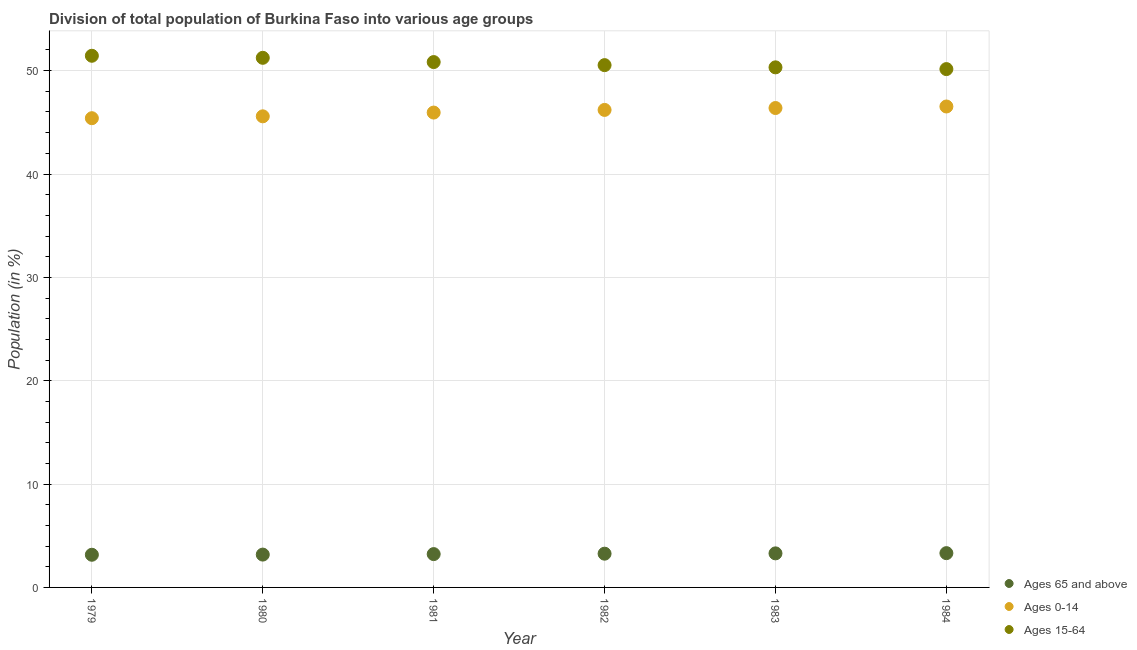How many different coloured dotlines are there?
Offer a very short reply. 3. What is the percentage of population within the age-group of 65 and above in 1981?
Provide a succinct answer. 3.22. Across all years, what is the maximum percentage of population within the age-group 15-64?
Your answer should be very brief. 51.44. Across all years, what is the minimum percentage of population within the age-group 15-64?
Make the answer very short. 50.15. In which year was the percentage of population within the age-group 0-14 maximum?
Your answer should be compact. 1984. In which year was the percentage of population within the age-group of 65 and above minimum?
Make the answer very short. 1979. What is the total percentage of population within the age-group of 65 and above in the graph?
Give a very brief answer. 19.44. What is the difference between the percentage of population within the age-group 15-64 in 1980 and that in 1983?
Offer a terse response. 0.92. What is the difference between the percentage of population within the age-group of 65 and above in 1982 and the percentage of population within the age-group 15-64 in 1981?
Offer a very short reply. -47.57. What is the average percentage of population within the age-group 0-14 per year?
Make the answer very short. 46.01. In the year 1984, what is the difference between the percentage of population within the age-group of 65 and above and percentage of population within the age-group 15-64?
Offer a very short reply. -46.83. What is the ratio of the percentage of population within the age-group 15-64 in 1979 to that in 1983?
Your answer should be compact. 1.02. What is the difference between the highest and the second highest percentage of population within the age-group of 65 and above?
Keep it short and to the point. 0.02. What is the difference between the highest and the lowest percentage of population within the age-group 0-14?
Your response must be concise. 1.13. Is the sum of the percentage of population within the age-group of 65 and above in 1982 and 1983 greater than the maximum percentage of population within the age-group 15-64 across all years?
Make the answer very short. No. Is it the case that in every year, the sum of the percentage of population within the age-group of 65 and above and percentage of population within the age-group 0-14 is greater than the percentage of population within the age-group 15-64?
Provide a short and direct response. No. Does the percentage of population within the age-group 0-14 monotonically increase over the years?
Provide a short and direct response. Yes. Is the percentage of population within the age-group 15-64 strictly greater than the percentage of population within the age-group 0-14 over the years?
Keep it short and to the point. Yes. How many dotlines are there?
Offer a very short reply. 3. Are the values on the major ticks of Y-axis written in scientific E-notation?
Offer a very short reply. No. Does the graph contain any zero values?
Your response must be concise. No. How many legend labels are there?
Make the answer very short. 3. How are the legend labels stacked?
Provide a short and direct response. Vertical. What is the title of the graph?
Offer a very short reply. Division of total population of Burkina Faso into various age groups
. Does "Social Protection" appear as one of the legend labels in the graph?
Your answer should be compact. No. What is the label or title of the X-axis?
Your answer should be very brief. Year. What is the label or title of the Y-axis?
Provide a short and direct response. Population (in %). What is the Population (in %) in Ages 65 and above in 1979?
Your answer should be compact. 3.16. What is the Population (in %) of Ages 0-14 in 1979?
Make the answer very short. 45.4. What is the Population (in %) in Ages 15-64 in 1979?
Ensure brevity in your answer.  51.44. What is the Population (in %) of Ages 65 and above in 1980?
Offer a terse response. 3.18. What is the Population (in %) in Ages 0-14 in 1980?
Offer a terse response. 45.58. What is the Population (in %) of Ages 15-64 in 1980?
Your answer should be very brief. 51.24. What is the Population (in %) of Ages 65 and above in 1981?
Ensure brevity in your answer.  3.22. What is the Population (in %) in Ages 0-14 in 1981?
Your response must be concise. 45.94. What is the Population (in %) in Ages 15-64 in 1981?
Your answer should be very brief. 50.83. What is the Population (in %) in Ages 65 and above in 1982?
Make the answer very short. 3.26. What is the Population (in %) of Ages 0-14 in 1982?
Ensure brevity in your answer.  46.2. What is the Population (in %) in Ages 15-64 in 1982?
Provide a succinct answer. 50.53. What is the Population (in %) in Ages 65 and above in 1983?
Keep it short and to the point. 3.3. What is the Population (in %) in Ages 0-14 in 1983?
Make the answer very short. 46.38. What is the Population (in %) in Ages 15-64 in 1983?
Keep it short and to the point. 50.32. What is the Population (in %) of Ages 65 and above in 1984?
Make the answer very short. 3.32. What is the Population (in %) of Ages 0-14 in 1984?
Your answer should be very brief. 46.53. What is the Population (in %) in Ages 15-64 in 1984?
Make the answer very short. 50.15. Across all years, what is the maximum Population (in %) of Ages 65 and above?
Keep it short and to the point. 3.32. Across all years, what is the maximum Population (in %) in Ages 0-14?
Your response must be concise. 46.53. Across all years, what is the maximum Population (in %) in Ages 15-64?
Keep it short and to the point. 51.44. Across all years, what is the minimum Population (in %) of Ages 65 and above?
Your answer should be compact. 3.16. Across all years, what is the minimum Population (in %) in Ages 0-14?
Your response must be concise. 45.4. Across all years, what is the minimum Population (in %) in Ages 15-64?
Your answer should be very brief. 50.15. What is the total Population (in %) in Ages 65 and above in the graph?
Offer a very short reply. 19.44. What is the total Population (in %) of Ages 0-14 in the graph?
Your response must be concise. 276.04. What is the total Population (in %) in Ages 15-64 in the graph?
Your response must be concise. 304.52. What is the difference between the Population (in %) of Ages 65 and above in 1979 and that in 1980?
Give a very brief answer. -0.02. What is the difference between the Population (in %) of Ages 0-14 in 1979 and that in 1980?
Your response must be concise. -0.18. What is the difference between the Population (in %) in Ages 15-64 in 1979 and that in 1980?
Your response must be concise. 0.2. What is the difference between the Population (in %) in Ages 65 and above in 1979 and that in 1981?
Ensure brevity in your answer.  -0.06. What is the difference between the Population (in %) in Ages 0-14 in 1979 and that in 1981?
Provide a succinct answer. -0.55. What is the difference between the Population (in %) in Ages 15-64 in 1979 and that in 1981?
Your answer should be compact. 0.61. What is the difference between the Population (in %) of Ages 65 and above in 1979 and that in 1982?
Ensure brevity in your answer.  -0.1. What is the difference between the Population (in %) of Ages 0-14 in 1979 and that in 1982?
Offer a terse response. -0.8. What is the difference between the Population (in %) of Ages 15-64 in 1979 and that in 1982?
Provide a short and direct response. 0.91. What is the difference between the Population (in %) of Ages 65 and above in 1979 and that in 1983?
Provide a short and direct response. -0.13. What is the difference between the Population (in %) in Ages 0-14 in 1979 and that in 1983?
Offer a very short reply. -0.99. What is the difference between the Population (in %) of Ages 15-64 in 1979 and that in 1983?
Provide a succinct answer. 1.12. What is the difference between the Population (in %) of Ages 65 and above in 1979 and that in 1984?
Give a very brief answer. -0.16. What is the difference between the Population (in %) in Ages 0-14 in 1979 and that in 1984?
Offer a terse response. -1.13. What is the difference between the Population (in %) in Ages 15-64 in 1979 and that in 1984?
Provide a succinct answer. 1.29. What is the difference between the Population (in %) in Ages 65 and above in 1980 and that in 1981?
Your answer should be compact. -0.05. What is the difference between the Population (in %) in Ages 0-14 in 1980 and that in 1981?
Keep it short and to the point. -0.36. What is the difference between the Population (in %) in Ages 15-64 in 1980 and that in 1981?
Your answer should be compact. 0.41. What is the difference between the Population (in %) in Ages 65 and above in 1980 and that in 1982?
Make the answer very short. -0.09. What is the difference between the Population (in %) of Ages 0-14 in 1980 and that in 1982?
Give a very brief answer. -0.62. What is the difference between the Population (in %) in Ages 15-64 in 1980 and that in 1982?
Provide a succinct answer. 0.71. What is the difference between the Population (in %) in Ages 65 and above in 1980 and that in 1983?
Your response must be concise. -0.12. What is the difference between the Population (in %) in Ages 0-14 in 1980 and that in 1983?
Make the answer very short. -0.8. What is the difference between the Population (in %) in Ages 15-64 in 1980 and that in 1983?
Offer a terse response. 0.92. What is the difference between the Population (in %) of Ages 65 and above in 1980 and that in 1984?
Provide a short and direct response. -0.14. What is the difference between the Population (in %) of Ages 0-14 in 1980 and that in 1984?
Your response must be concise. -0.95. What is the difference between the Population (in %) of Ages 15-64 in 1980 and that in 1984?
Offer a very short reply. 1.09. What is the difference between the Population (in %) in Ages 65 and above in 1981 and that in 1982?
Keep it short and to the point. -0.04. What is the difference between the Population (in %) in Ages 0-14 in 1981 and that in 1982?
Provide a succinct answer. -0.26. What is the difference between the Population (in %) of Ages 15-64 in 1981 and that in 1982?
Offer a terse response. 0.3. What is the difference between the Population (in %) of Ages 65 and above in 1981 and that in 1983?
Your response must be concise. -0.07. What is the difference between the Population (in %) of Ages 0-14 in 1981 and that in 1983?
Offer a terse response. -0.44. What is the difference between the Population (in %) of Ages 15-64 in 1981 and that in 1983?
Make the answer very short. 0.51. What is the difference between the Population (in %) in Ages 65 and above in 1981 and that in 1984?
Keep it short and to the point. -0.09. What is the difference between the Population (in %) in Ages 0-14 in 1981 and that in 1984?
Your response must be concise. -0.59. What is the difference between the Population (in %) in Ages 15-64 in 1981 and that in 1984?
Ensure brevity in your answer.  0.68. What is the difference between the Population (in %) of Ages 65 and above in 1982 and that in 1983?
Your response must be concise. -0.03. What is the difference between the Population (in %) in Ages 0-14 in 1982 and that in 1983?
Your response must be concise. -0.18. What is the difference between the Population (in %) of Ages 15-64 in 1982 and that in 1983?
Your answer should be very brief. 0.21. What is the difference between the Population (in %) of Ages 65 and above in 1982 and that in 1984?
Make the answer very short. -0.05. What is the difference between the Population (in %) in Ages 0-14 in 1982 and that in 1984?
Offer a terse response. -0.33. What is the difference between the Population (in %) in Ages 15-64 in 1982 and that in 1984?
Provide a short and direct response. 0.38. What is the difference between the Population (in %) of Ages 65 and above in 1983 and that in 1984?
Your answer should be compact. -0.02. What is the difference between the Population (in %) of Ages 0-14 in 1983 and that in 1984?
Your answer should be compact. -0.15. What is the difference between the Population (in %) in Ages 15-64 in 1983 and that in 1984?
Offer a very short reply. 0.17. What is the difference between the Population (in %) of Ages 65 and above in 1979 and the Population (in %) of Ages 0-14 in 1980?
Your answer should be very brief. -42.42. What is the difference between the Population (in %) in Ages 65 and above in 1979 and the Population (in %) in Ages 15-64 in 1980?
Ensure brevity in your answer.  -48.08. What is the difference between the Population (in %) in Ages 0-14 in 1979 and the Population (in %) in Ages 15-64 in 1980?
Offer a terse response. -5.84. What is the difference between the Population (in %) in Ages 65 and above in 1979 and the Population (in %) in Ages 0-14 in 1981?
Your answer should be very brief. -42.78. What is the difference between the Population (in %) of Ages 65 and above in 1979 and the Population (in %) of Ages 15-64 in 1981?
Give a very brief answer. -47.67. What is the difference between the Population (in %) of Ages 0-14 in 1979 and the Population (in %) of Ages 15-64 in 1981?
Your response must be concise. -5.43. What is the difference between the Population (in %) in Ages 65 and above in 1979 and the Population (in %) in Ages 0-14 in 1982?
Provide a succinct answer. -43.04. What is the difference between the Population (in %) in Ages 65 and above in 1979 and the Population (in %) in Ages 15-64 in 1982?
Make the answer very short. -47.37. What is the difference between the Population (in %) in Ages 0-14 in 1979 and the Population (in %) in Ages 15-64 in 1982?
Your answer should be compact. -5.13. What is the difference between the Population (in %) in Ages 65 and above in 1979 and the Population (in %) in Ages 0-14 in 1983?
Give a very brief answer. -43.22. What is the difference between the Population (in %) in Ages 65 and above in 1979 and the Population (in %) in Ages 15-64 in 1983?
Keep it short and to the point. -47.16. What is the difference between the Population (in %) in Ages 0-14 in 1979 and the Population (in %) in Ages 15-64 in 1983?
Your answer should be very brief. -4.92. What is the difference between the Population (in %) of Ages 65 and above in 1979 and the Population (in %) of Ages 0-14 in 1984?
Make the answer very short. -43.37. What is the difference between the Population (in %) of Ages 65 and above in 1979 and the Population (in %) of Ages 15-64 in 1984?
Make the answer very short. -46.99. What is the difference between the Population (in %) in Ages 0-14 in 1979 and the Population (in %) in Ages 15-64 in 1984?
Offer a very short reply. -4.75. What is the difference between the Population (in %) of Ages 65 and above in 1980 and the Population (in %) of Ages 0-14 in 1981?
Your answer should be compact. -42.77. What is the difference between the Population (in %) in Ages 65 and above in 1980 and the Population (in %) in Ages 15-64 in 1981?
Make the answer very short. -47.65. What is the difference between the Population (in %) in Ages 0-14 in 1980 and the Population (in %) in Ages 15-64 in 1981?
Your answer should be very brief. -5.25. What is the difference between the Population (in %) of Ages 65 and above in 1980 and the Population (in %) of Ages 0-14 in 1982?
Keep it short and to the point. -43.02. What is the difference between the Population (in %) in Ages 65 and above in 1980 and the Population (in %) in Ages 15-64 in 1982?
Ensure brevity in your answer.  -47.36. What is the difference between the Population (in %) of Ages 0-14 in 1980 and the Population (in %) of Ages 15-64 in 1982?
Offer a very short reply. -4.95. What is the difference between the Population (in %) in Ages 65 and above in 1980 and the Population (in %) in Ages 0-14 in 1983?
Your answer should be compact. -43.21. What is the difference between the Population (in %) in Ages 65 and above in 1980 and the Population (in %) in Ages 15-64 in 1983?
Keep it short and to the point. -47.14. What is the difference between the Population (in %) in Ages 0-14 in 1980 and the Population (in %) in Ages 15-64 in 1983?
Give a very brief answer. -4.74. What is the difference between the Population (in %) in Ages 65 and above in 1980 and the Population (in %) in Ages 0-14 in 1984?
Ensure brevity in your answer.  -43.36. What is the difference between the Population (in %) in Ages 65 and above in 1980 and the Population (in %) in Ages 15-64 in 1984?
Offer a very short reply. -46.97. What is the difference between the Population (in %) in Ages 0-14 in 1980 and the Population (in %) in Ages 15-64 in 1984?
Your answer should be compact. -4.57. What is the difference between the Population (in %) of Ages 65 and above in 1981 and the Population (in %) of Ages 0-14 in 1982?
Provide a short and direct response. -42.98. What is the difference between the Population (in %) of Ages 65 and above in 1981 and the Population (in %) of Ages 15-64 in 1982?
Your answer should be compact. -47.31. What is the difference between the Population (in %) in Ages 0-14 in 1981 and the Population (in %) in Ages 15-64 in 1982?
Your answer should be very brief. -4.59. What is the difference between the Population (in %) in Ages 65 and above in 1981 and the Population (in %) in Ages 0-14 in 1983?
Offer a terse response. -43.16. What is the difference between the Population (in %) of Ages 65 and above in 1981 and the Population (in %) of Ages 15-64 in 1983?
Offer a very short reply. -47.09. What is the difference between the Population (in %) in Ages 0-14 in 1981 and the Population (in %) in Ages 15-64 in 1983?
Provide a short and direct response. -4.37. What is the difference between the Population (in %) in Ages 65 and above in 1981 and the Population (in %) in Ages 0-14 in 1984?
Provide a succinct answer. -43.31. What is the difference between the Population (in %) in Ages 65 and above in 1981 and the Population (in %) in Ages 15-64 in 1984?
Your answer should be compact. -46.93. What is the difference between the Population (in %) in Ages 0-14 in 1981 and the Population (in %) in Ages 15-64 in 1984?
Your response must be concise. -4.21. What is the difference between the Population (in %) in Ages 65 and above in 1982 and the Population (in %) in Ages 0-14 in 1983?
Your response must be concise. -43.12. What is the difference between the Population (in %) of Ages 65 and above in 1982 and the Population (in %) of Ages 15-64 in 1983?
Your response must be concise. -47.06. What is the difference between the Population (in %) of Ages 0-14 in 1982 and the Population (in %) of Ages 15-64 in 1983?
Give a very brief answer. -4.12. What is the difference between the Population (in %) in Ages 65 and above in 1982 and the Population (in %) in Ages 0-14 in 1984?
Provide a short and direct response. -43.27. What is the difference between the Population (in %) in Ages 65 and above in 1982 and the Population (in %) in Ages 15-64 in 1984?
Provide a short and direct response. -46.89. What is the difference between the Population (in %) in Ages 0-14 in 1982 and the Population (in %) in Ages 15-64 in 1984?
Make the answer very short. -3.95. What is the difference between the Population (in %) of Ages 65 and above in 1983 and the Population (in %) of Ages 0-14 in 1984?
Keep it short and to the point. -43.24. What is the difference between the Population (in %) of Ages 65 and above in 1983 and the Population (in %) of Ages 15-64 in 1984?
Offer a terse response. -46.86. What is the difference between the Population (in %) in Ages 0-14 in 1983 and the Population (in %) in Ages 15-64 in 1984?
Offer a terse response. -3.77. What is the average Population (in %) of Ages 65 and above per year?
Keep it short and to the point. 3.24. What is the average Population (in %) of Ages 0-14 per year?
Your answer should be very brief. 46.01. What is the average Population (in %) of Ages 15-64 per year?
Offer a terse response. 50.75. In the year 1979, what is the difference between the Population (in %) of Ages 65 and above and Population (in %) of Ages 0-14?
Provide a short and direct response. -42.24. In the year 1979, what is the difference between the Population (in %) of Ages 65 and above and Population (in %) of Ages 15-64?
Make the answer very short. -48.28. In the year 1979, what is the difference between the Population (in %) in Ages 0-14 and Population (in %) in Ages 15-64?
Your answer should be very brief. -6.04. In the year 1980, what is the difference between the Population (in %) of Ages 65 and above and Population (in %) of Ages 0-14?
Give a very brief answer. -42.4. In the year 1980, what is the difference between the Population (in %) of Ages 65 and above and Population (in %) of Ages 15-64?
Make the answer very short. -48.07. In the year 1980, what is the difference between the Population (in %) of Ages 0-14 and Population (in %) of Ages 15-64?
Keep it short and to the point. -5.66. In the year 1981, what is the difference between the Population (in %) in Ages 65 and above and Population (in %) in Ages 0-14?
Keep it short and to the point. -42.72. In the year 1981, what is the difference between the Population (in %) of Ages 65 and above and Population (in %) of Ages 15-64?
Provide a succinct answer. -47.61. In the year 1981, what is the difference between the Population (in %) in Ages 0-14 and Population (in %) in Ages 15-64?
Ensure brevity in your answer.  -4.89. In the year 1982, what is the difference between the Population (in %) in Ages 65 and above and Population (in %) in Ages 0-14?
Offer a terse response. -42.94. In the year 1982, what is the difference between the Population (in %) in Ages 65 and above and Population (in %) in Ages 15-64?
Give a very brief answer. -47.27. In the year 1982, what is the difference between the Population (in %) of Ages 0-14 and Population (in %) of Ages 15-64?
Your answer should be very brief. -4.33. In the year 1983, what is the difference between the Population (in %) in Ages 65 and above and Population (in %) in Ages 0-14?
Give a very brief answer. -43.09. In the year 1983, what is the difference between the Population (in %) of Ages 65 and above and Population (in %) of Ages 15-64?
Make the answer very short. -47.02. In the year 1983, what is the difference between the Population (in %) of Ages 0-14 and Population (in %) of Ages 15-64?
Provide a short and direct response. -3.94. In the year 1984, what is the difference between the Population (in %) in Ages 65 and above and Population (in %) in Ages 0-14?
Provide a short and direct response. -43.22. In the year 1984, what is the difference between the Population (in %) in Ages 65 and above and Population (in %) in Ages 15-64?
Provide a succinct answer. -46.83. In the year 1984, what is the difference between the Population (in %) in Ages 0-14 and Population (in %) in Ages 15-64?
Offer a terse response. -3.62. What is the ratio of the Population (in %) in Ages 65 and above in 1979 to that in 1980?
Your answer should be compact. 0.99. What is the ratio of the Population (in %) of Ages 0-14 in 1979 to that in 1980?
Ensure brevity in your answer.  1. What is the ratio of the Population (in %) in Ages 15-64 in 1979 to that in 1980?
Give a very brief answer. 1. What is the ratio of the Population (in %) in Ages 65 and above in 1979 to that in 1981?
Provide a short and direct response. 0.98. What is the ratio of the Population (in %) in Ages 0-14 in 1979 to that in 1981?
Your answer should be very brief. 0.99. What is the ratio of the Population (in %) in Ages 65 and above in 1979 to that in 1982?
Ensure brevity in your answer.  0.97. What is the ratio of the Population (in %) in Ages 0-14 in 1979 to that in 1982?
Ensure brevity in your answer.  0.98. What is the ratio of the Population (in %) of Ages 15-64 in 1979 to that in 1982?
Give a very brief answer. 1.02. What is the ratio of the Population (in %) in Ages 65 and above in 1979 to that in 1983?
Offer a terse response. 0.96. What is the ratio of the Population (in %) in Ages 0-14 in 1979 to that in 1983?
Offer a terse response. 0.98. What is the ratio of the Population (in %) in Ages 15-64 in 1979 to that in 1983?
Offer a terse response. 1.02. What is the ratio of the Population (in %) of Ages 65 and above in 1979 to that in 1984?
Offer a very short reply. 0.95. What is the ratio of the Population (in %) of Ages 0-14 in 1979 to that in 1984?
Your answer should be very brief. 0.98. What is the ratio of the Population (in %) of Ages 15-64 in 1979 to that in 1984?
Make the answer very short. 1.03. What is the ratio of the Population (in %) in Ages 65 and above in 1980 to that in 1981?
Provide a short and direct response. 0.99. What is the ratio of the Population (in %) of Ages 0-14 in 1980 to that in 1981?
Offer a very short reply. 0.99. What is the ratio of the Population (in %) of Ages 15-64 in 1980 to that in 1981?
Offer a very short reply. 1.01. What is the ratio of the Population (in %) in Ages 65 and above in 1980 to that in 1982?
Your response must be concise. 0.97. What is the ratio of the Population (in %) of Ages 0-14 in 1980 to that in 1982?
Offer a terse response. 0.99. What is the ratio of the Population (in %) of Ages 15-64 in 1980 to that in 1982?
Offer a terse response. 1.01. What is the ratio of the Population (in %) of Ages 65 and above in 1980 to that in 1983?
Offer a terse response. 0.96. What is the ratio of the Population (in %) of Ages 0-14 in 1980 to that in 1983?
Your response must be concise. 0.98. What is the ratio of the Population (in %) in Ages 15-64 in 1980 to that in 1983?
Your answer should be very brief. 1.02. What is the ratio of the Population (in %) of Ages 65 and above in 1980 to that in 1984?
Ensure brevity in your answer.  0.96. What is the ratio of the Population (in %) in Ages 0-14 in 1980 to that in 1984?
Keep it short and to the point. 0.98. What is the ratio of the Population (in %) of Ages 15-64 in 1980 to that in 1984?
Give a very brief answer. 1.02. What is the ratio of the Population (in %) in Ages 0-14 in 1981 to that in 1982?
Make the answer very short. 0.99. What is the ratio of the Population (in %) of Ages 15-64 in 1981 to that in 1982?
Provide a short and direct response. 1.01. What is the ratio of the Population (in %) in Ages 65 and above in 1981 to that in 1983?
Keep it short and to the point. 0.98. What is the ratio of the Population (in %) in Ages 0-14 in 1981 to that in 1983?
Your answer should be compact. 0.99. What is the ratio of the Population (in %) in Ages 15-64 in 1981 to that in 1983?
Make the answer very short. 1.01. What is the ratio of the Population (in %) of Ages 65 and above in 1981 to that in 1984?
Give a very brief answer. 0.97. What is the ratio of the Population (in %) in Ages 0-14 in 1981 to that in 1984?
Offer a terse response. 0.99. What is the ratio of the Population (in %) in Ages 15-64 in 1981 to that in 1984?
Your response must be concise. 1.01. What is the ratio of the Population (in %) in Ages 65 and above in 1982 to that in 1983?
Provide a short and direct response. 0.99. What is the ratio of the Population (in %) of Ages 0-14 in 1982 to that in 1983?
Offer a very short reply. 1. What is the ratio of the Population (in %) in Ages 15-64 in 1982 to that in 1983?
Give a very brief answer. 1. What is the ratio of the Population (in %) of Ages 65 and above in 1982 to that in 1984?
Give a very brief answer. 0.98. What is the ratio of the Population (in %) of Ages 0-14 in 1982 to that in 1984?
Offer a very short reply. 0.99. What is the ratio of the Population (in %) in Ages 15-64 in 1982 to that in 1984?
Provide a succinct answer. 1.01. What is the ratio of the Population (in %) of Ages 65 and above in 1983 to that in 1984?
Provide a short and direct response. 0.99. What is the ratio of the Population (in %) in Ages 15-64 in 1983 to that in 1984?
Offer a terse response. 1. What is the difference between the highest and the second highest Population (in %) of Ages 65 and above?
Ensure brevity in your answer.  0.02. What is the difference between the highest and the second highest Population (in %) of Ages 0-14?
Make the answer very short. 0.15. What is the difference between the highest and the second highest Population (in %) in Ages 15-64?
Provide a short and direct response. 0.2. What is the difference between the highest and the lowest Population (in %) in Ages 65 and above?
Provide a succinct answer. 0.16. What is the difference between the highest and the lowest Population (in %) of Ages 0-14?
Give a very brief answer. 1.13. What is the difference between the highest and the lowest Population (in %) in Ages 15-64?
Keep it short and to the point. 1.29. 